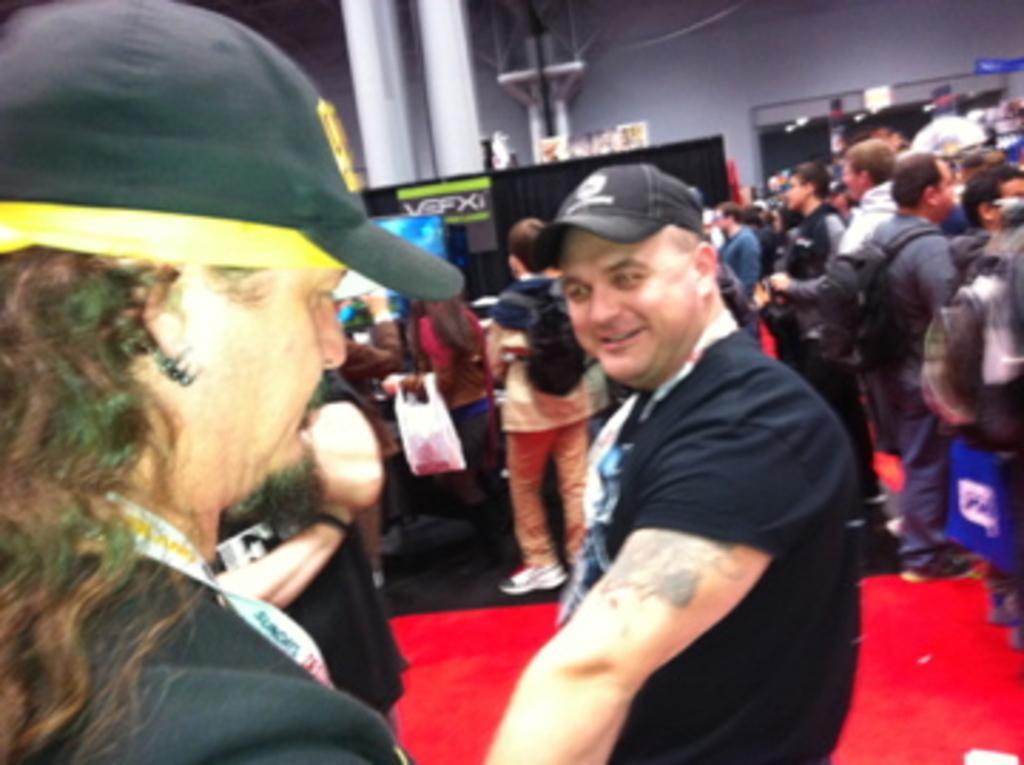Please provide a concise description of this image. This picture shows few people standing and we see couple of them wore caps on their heads and they wore id cards and we see few of them wore backpack on their back and we see a woman holding a carry bag in her hand. 